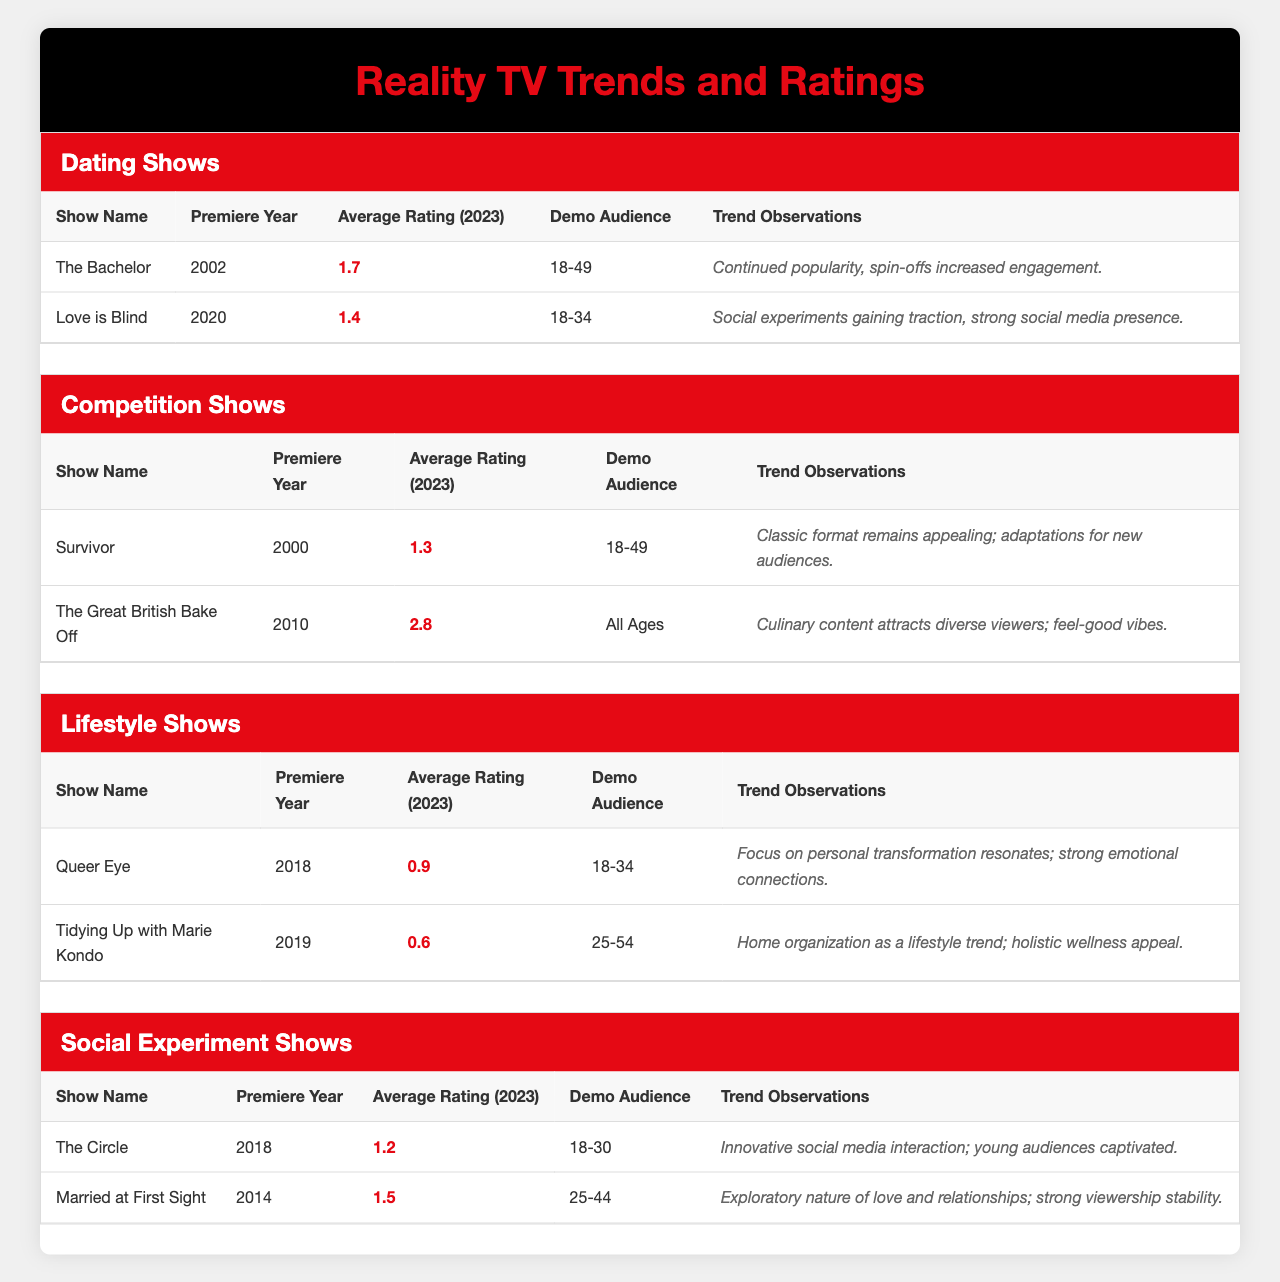What is the average rating of "The Great British Bake Off"? The average rating for "The Great British Bake Off" is displayed in its row, which shows 2.8.
Answer: 2.8 Which show has the lowest average rating in the Lifestyle Shows category? In the Lifestyle Shows category, the show "Tidying Up with Marie Kondo" has an average rating of 0.6, which is lower than "Queer Eye" at 0.9.
Answer: Tidying Up with Marie Kondo Is "Love is Blind" targeting a younger demographic than "The Bachelor"? "Love is Blind" targets the 18-34 demographic, while "The Bachelor" targets the 18-49 demographic. Since 18-34 is younger than 18-49, the statement is true.
Answer: Yes What is the trend observation for "Survivor"? The trend observation for "Survivor" is stated as "Classic format remains appealing; adaptations for new audiences." This is found directly in its row.
Answer: Classic format remains appealing; adaptations for new audiences If we consider the ratings of all the Lifestyle Shows, what is their average rating? The ratings for the Lifestyle Shows are 0.9 for "Queer Eye" and 0.6 for "Tidying Up with Marie Kondo". To find the average: (0.9 + 0.6) / 2 = 1.5 / 2 = 0.75.
Answer: 0.75 Which competition show has the highest average rating? Among the competition shows, "The Great British Bake Off" has the highest average rating of 2.8, compared to "Survivor" which has 1.3.
Answer: The Great British Bake Off Are there more shows in the Dating Shows category or in the Competition Shows category? Both categories contain 2 shows each: "The Bachelor" and "Love is Blind" for Dating Shows, and "Survivor" and "The Great British Bake Off" for Competition Shows. Therefore, they are equal.
Answer: Equal What trend observations can be inferred from the Social Experiment Shows? "The Circle" notes innovative social media interaction appealing to young audiences, while "Married at First Sight" explores love and relationships with strong viewership stability. Summarizing these highlights both social engagement and relationship exploration.
Answer: Innovative social media interaction; strong viewership stability 